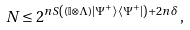<formula> <loc_0><loc_0><loc_500><loc_500>N \leq 2 ^ { n S \left ( ( \mathbb { I } \otimes \Lambda ) | \Psi ^ { + } \rangle \langle \Psi ^ { + } | \right ) + 2 n \delta } \, ,</formula> 